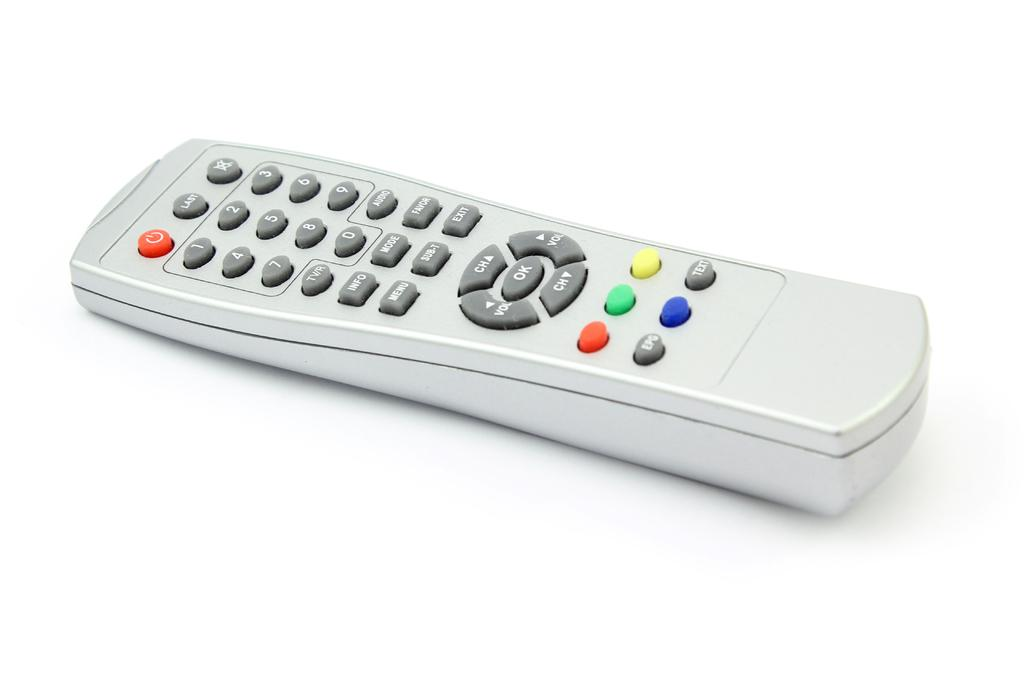<image>
Give a short and clear explanation of the subsequent image. White controller with the OK button in the middle. 